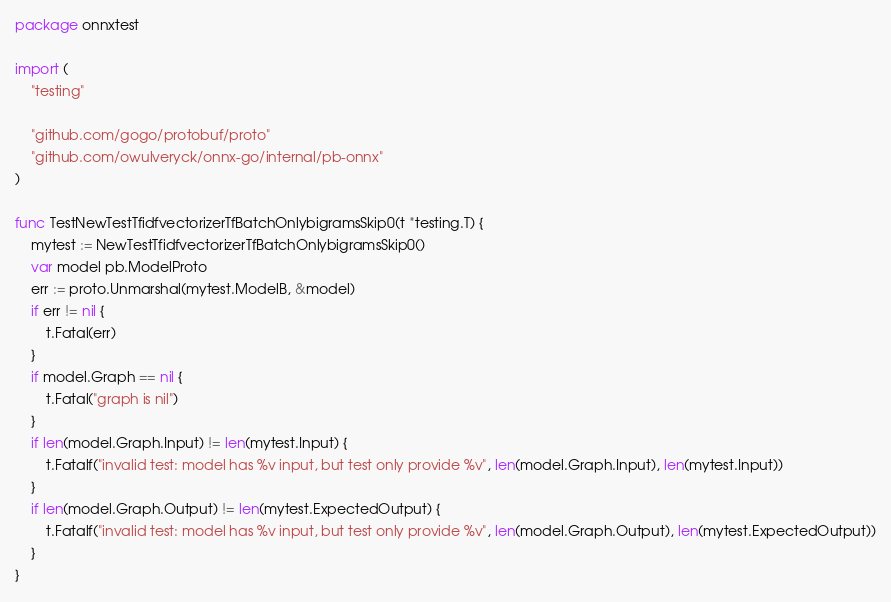<code> <loc_0><loc_0><loc_500><loc_500><_Go_>package onnxtest

import (
	"testing"

	"github.com/gogo/protobuf/proto"
	"github.com/owulveryck/onnx-go/internal/pb-onnx"
)

func TestNewTestTfidfvectorizerTfBatchOnlybigramsSkip0(t *testing.T) {
	mytest := NewTestTfidfvectorizerTfBatchOnlybigramsSkip0()
	var model pb.ModelProto
	err := proto.Unmarshal(mytest.ModelB, &model)
	if err != nil {
		t.Fatal(err)
	}
	if model.Graph == nil {
		t.Fatal("graph is nil")
	}
	if len(model.Graph.Input) != len(mytest.Input) {
		t.Fatalf("invalid test: model has %v input, but test only provide %v", len(model.Graph.Input), len(mytest.Input))
	}
	if len(model.Graph.Output) != len(mytest.ExpectedOutput) {
		t.Fatalf("invalid test: model has %v input, but test only provide %v", len(model.Graph.Output), len(mytest.ExpectedOutput))
	}
}
</code> 